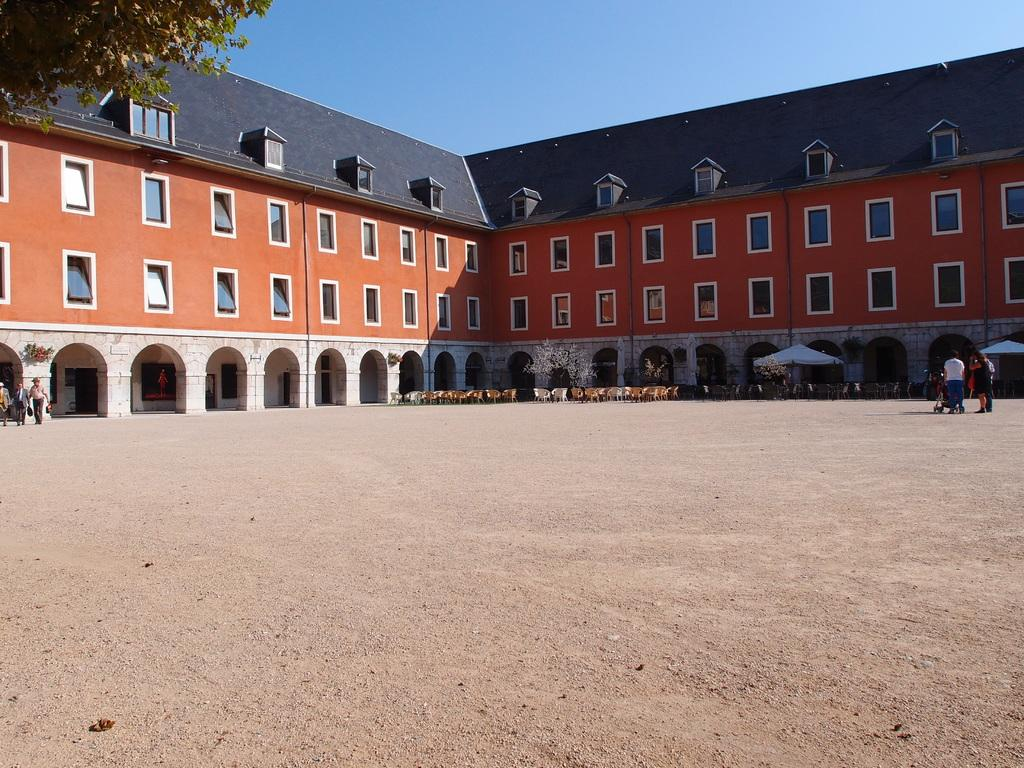How many groups of persons can be seen in the image? There are two groups of persons in the image, one in the left corner and one in the right corner. What is visible in the background of the image? There is a building and chairs in the background of the image. What type of beggar can be seen in the image? There is no beggar present in the image. What kind of apparatus is being used by the persons in the image? There is no apparatus visible in the image; the persons are simply standing in the corners. 